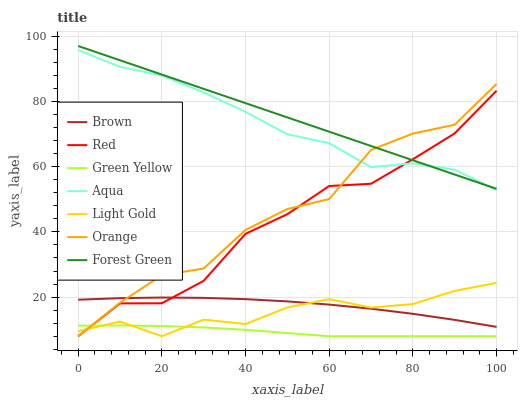Does Green Yellow have the minimum area under the curve?
Answer yes or no. Yes. Does Aqua have the minimum area under the curve?
Answer yes or no. No. Does Aqua have the maximum area under the curve?
Answer yes or no. No. Is Orange the roughest?
Answer yes or no. Yes. Is Aqua the smoothest?
Answer yes or no. No. Is Aqua the roughest?
Answer yes or no. No. Does Aqua have the lowest value?
Answer yes or no. No. Does Aqua have the highest value?
Answer yes or no. No. Is Light Gold less than Aqua?
Answer yes or no. Yes. Is Aqua greater than Green Yellow?
Answer yes or no. Yes. Does Light Gold intersect Aqua?
Answer yes or no. No. 